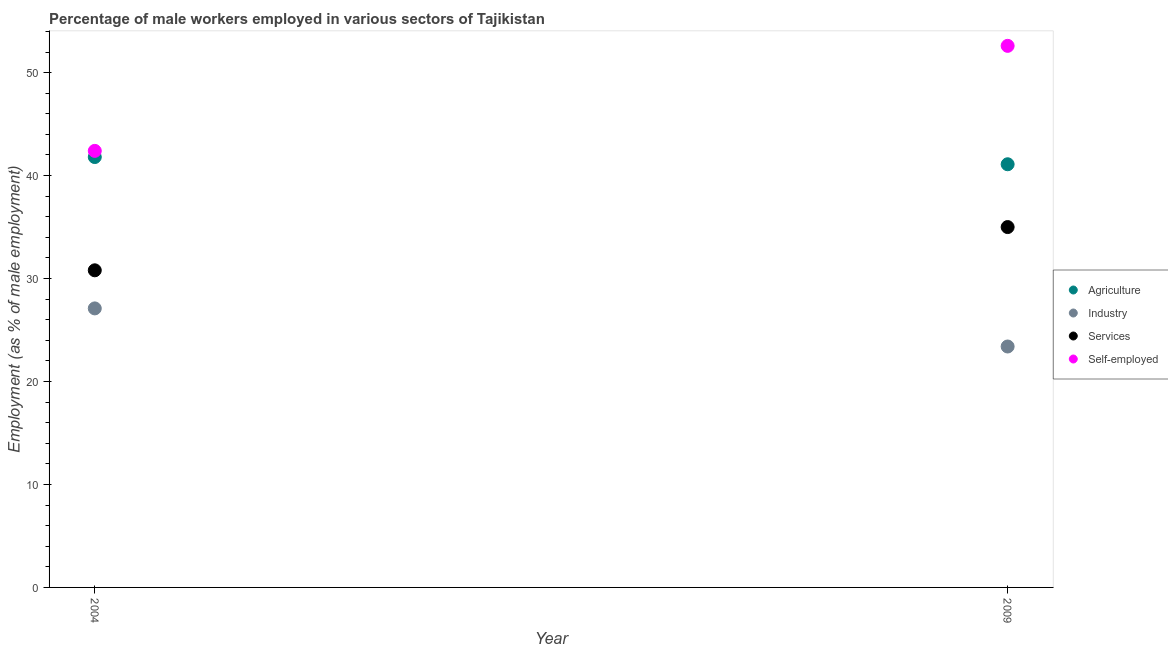How many different coloured dotlines are there?
Offer a very short reply. 4. What is the percentage of male workers in services in 2004?
Ensure brevity in your answer.  30.8. Across all years, what is the maximum percentage of male workers in agriculture?
Offer a terse response. 41.8. Across all years, what is the minimum percentage of self employed male workers?
Give a very brief answer. 42.4. What is the total percentage of male workers in industry in the graph?
Your answer should be compact. 50.5. What is the difference between the percentage of male workers in services in 2004 and that in 2009?
Provide a short and direct response. -4.2. What is the difference between the percentage of male workers in industry in 2009 and the percentage of self employed male workers in 2004?
Offer a very short reply. -19. What is the average percentage of self employed male workers per year?
Offer a very short reply. 47.5. In the year 2009, what is the difference between the percentage of male workers in services and percentage of male workers in agriculture?
Your response must be concise. -6.1. In how many years, is the percentage of self employed male workers greater than 26 %?
Keep it short and to the point. 2. What is the ratio of the percentage of male workers in agriculture in 2004 to that in 2009?
Your answer should be compact. 1.02. In how many years, is the percentage of male workers in services greater than the average percentage of male workers in services taken over all years?
Give a very brief answer. 1. Is it the case that in every year, the sum of the percentage of male workers in agriculture and percentage of male workers in industry is greater than the percentage of male workers in services?
Make the answer very short. Yes. Is the percentage of self employed male workers strictly greater than the percentage of male workers in agriculture over the years?
Make the answer very short. Yes. How many years are there in the graph?
Offer a terse response. 2. What is the difference between two consecutive major ticks on the Y-axis?
Your response must be concise. 10. Are the values on the major ticks of Y-axis written in scientific E-notation?
Provide a short and direct response. No. Does the graph contain grids?
Your answer should be very brief. No. How many legend labels are there?
Give a very brief answer. 4. How are the legend labels stacked?
Ensure brevity in your answer.  Vertical. What is the title of the graph?
Your answer should be very brief. Percentage of male workers employed in various sectors of Tajikistan. Does "Natural Gas" appear as one of the legend labels in the graph?
Your response must be concise. No. What is the label or title of the X-axis?
Keep it short and to the point. Year. What is the label or title of the Y-axis?
Offer a terse response. Employment (as % of male employment). What is the Employment (as % of male employment) of Agriculture in 2004?
Make the answer very short. 41.8. What is the Employment (as % of male employment) in Industry in 2004?
Your answer should be compact. 27.1. What is the Employment (as % of male employment) of Services in 2004?
Provide a succinct answer. 30.8. What is the Employment (as % of male employment) of Self-employed in 2004?
Provide a short and direct response. 42.4. What is the Employment (as % of male employment) of Agriculture in 2009?
Give a very brief answer. 41.1. What is the Employment (as % of male employment) in Industry in 2009?
Your answer should be compact. 23.4. What is the Employment (as % of male employment) of Self-employed in 2009?
Ensure brevity in your answer.  52.6. Across all years, what is the maximum Employment (as % of male employment) of Agriculture?
Make the answer very short. 41.8. Across all years, what is the maximum Employment (as % of male employment) in Industry?
Offer a very short reply. 27.1. Across all years, what is the maximum Employment (as % of male employment) of Self-employed?
Your answer should be compact. 52.6. Across all years, what is the minimum Employment (as % of male employment) in Agriculture?
Your answer should be compact. 41.1. Across all years, what is the minimum Employment (as % of male employment) of Industry?
Provide a short and direct response. 23.4. Across all years, what is the minimum Employment (as % of male employment) of Services?
Make the answer very short. 30.8. Across all years, what is the minimum Employment (as % of male employment) of Self-employed?
Make the answer very short. 42.4. What is the total Employment (as % of male employment) in Agriculture in the graph?
Your answer should be compact. 82.9. What is the total Employment (as % of male employment) of Industry in the graph?
Offer a very short reply. 50.5. What is the total Employment (as % of male employment) in Services in the graph?
Keep it short and to the point. 65.8. What is the total Employment (as % of male employment) of Self-employed in the graph?
Your answer should be very brief. 95. What is the difference between the Employment (as % of male employment) of Agriculture in 2004 and that in 2009?
Your answer should be compact. 0.7. What is the difference between the Employment (as % of male employment) of Industry in 2004 and the Employment (as % of male employment) of Services in 2009?
Your answer should be very brief. -7.9. What is the difference between the Employment (as % of male employment) in Industry in 2004 and the Employment (as % of male employment) in Self-employed in 2009?
Make the answer very short. -25.5. What is the difference between the Employment (as % of male employment) in Services in 2004 and the Employment (as % of male employment) in Self-employed in 2009?
Your response must be concise. -21.8. What is the average Employment (as % of male employment) in Agriculture per year?
Offer a terse response. 41.45. What is the average Employment (as % of male employment) of Industry per year?
Offer a terse response. 25.25. What is the average Employment (as % of male employment) in Services per year?
Keep it short and to the point. 32.9. What is the average Employment (as % of male employment) in Self-employed per year?
Your answer should be compact. 47.5. In the year 2004, what is the difference between the Employment (as % of male employment) in Agriculture and Employment (as % of male employment) in Industry?
Offer a terse response. 14.7. In the year 2004, what is the difference between the Employment (as % of male employment) in Agriculture and Employment (as % of male employment) in Self-employed?
Your response must be concise. -0.6. In the year 2004, what is the difference between the Employment (as % of male employment) in Industry and Employment (as % of male employment) in Self-employed?
Your answer should be compact. -15.3. In the year 2009, what is the difference between the Employment (as % of male employment) of Agriculture and Employment (as % of male employment) of Industry?
Give a very brief answer. 17.7. In the year 2009, what is the difference between the Employment (as % of male employment) in Agriculture and Employment (as % of male employment) in Services?
Provide a short and direct response. 6.1. In the year 2009, what is the difference between the Employment (as % of male employment) of Industry and Employment (as % of male employment) of Self-employed?
Provide a succinct answer. -29.2. In the year 2009, what is the difference between the Employment (as % of male employment) in Services and Employment (as % of male employment) in Self-employed?
Make the answer very short. -17.6. What is the ratio of the Employment (as % of male employment) of Industry in 2004 to that in 2009?
Provide a succinct answer. 1.16. What is the ratio of the Employment (as % of male employment) in Services in 2004 to that in 2009?
Your answer should be compact. 0.88. What is the ratio of the Employment (as % of male employment) in Self-employed in 2004 to that in 2009?
Offer a very short reply. 0.81. What is the difference between the highest and the second highest Employment (as % of male employment) of Agriculture?
Your answer should be compact. 0.7. What is the difference between the highest and the second highest Employment (as % of male employment) of Services?
Provide a succinct answer. 4.2. What is the difference between the highest and the second highest Employment (as % of male employment) in Self-employed?
Ensure brevity in your answer.  10.2. What is the difference between the highest and the lowest Employment (as % of male employment) in Industry?
Your answer should be very brief. 3.7. What is the difference between the highest and the lowest Employment (as % of male employment) in Self-employed?
Offer a very short reply. 10.2. 